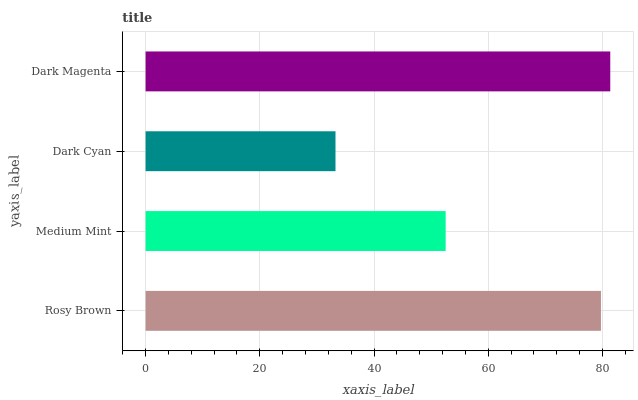Is Dark Cyan the minimum?
Answer yes or no. Yes. Is Dark Magenta the maximum?
Answer yes or no. Yes. Is Medium Mint the minimum?
Answer yes or no. No. Is Medium Mint the maximum?
Answer yes or no. No. Is Rosy Brown greater than Medium Mint?
Answer yes or no. Yes. Is Medium Mint less than Rosy Brown?
Answer yes or no. Yes. Is Medium Mint greater than Rosy Brown?
Answer yes or no. No. Is Rosy Brown less than Medium Mint?
Answer yes or no. No. Is Rosy Brown the high median?
Answer yes or no. Yes. Is Medium Mint the low median?
Answer yes or no. Yes. Is Dark Cyan the high median?
Answer yes or no. No. Is Dark Magenta the low median?
Answer yes or no. No. 